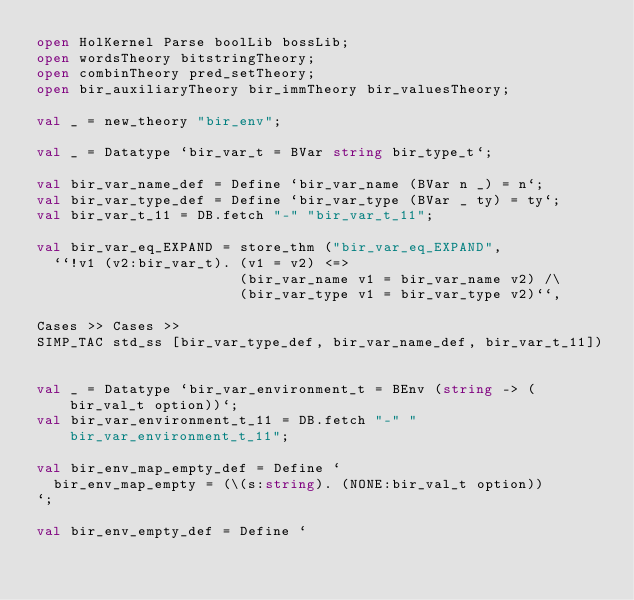<code> <loc_0><loc_0><loc_500><loc_500><_SML_>open HolKernel Parse boolLib bossLib;
open wordsTheory bitstringTheory;
open combinTheory pred_setTheory;
open bir_auxiliaryTheory bir_immTheory bir_valuesTheory;

val _ = new_theory "bir_env";

val _ = Datatype `bir_var_t = BVar string bir_type_t`;

val bir_var_name_def = Define `bir_var_name (BVar n _) = n`;
val bir_var_type_def = Define `bir_var_type (BVar _ ty) = ty`;
val bir_var_t_11 = DB.fetch "-" "bir_var_t_11";

val bir_var_eq_EXPAND = store_thm ("bir_var_eq_EXPAND",
  ``!v1 (v2:bir_var_t). (v1 = v2) <=>
                        (bir_var_name v1 = bir_var_name v2) /\
                        (bir_var_type v1 = bir_var_type v2)``,

Cases >> Cases >>
SIMP_TAC std_ss [bir_var_type_def, bir_var_name_def, bir_var_t_11])


val _ = Datatype `bir_var_environment_t = BEnv (string -> (bir_val_t option))`;
val bir_var_environment_t_11 = DB.fetch "-" "bir_var_environment_t_11";

val bir_env_map_empty_def = Define `
  bir_env_map_empty = (\(s:string). (NONE:bir_val_t option))
`;

val bir_env_empty_def = Define `</code> 